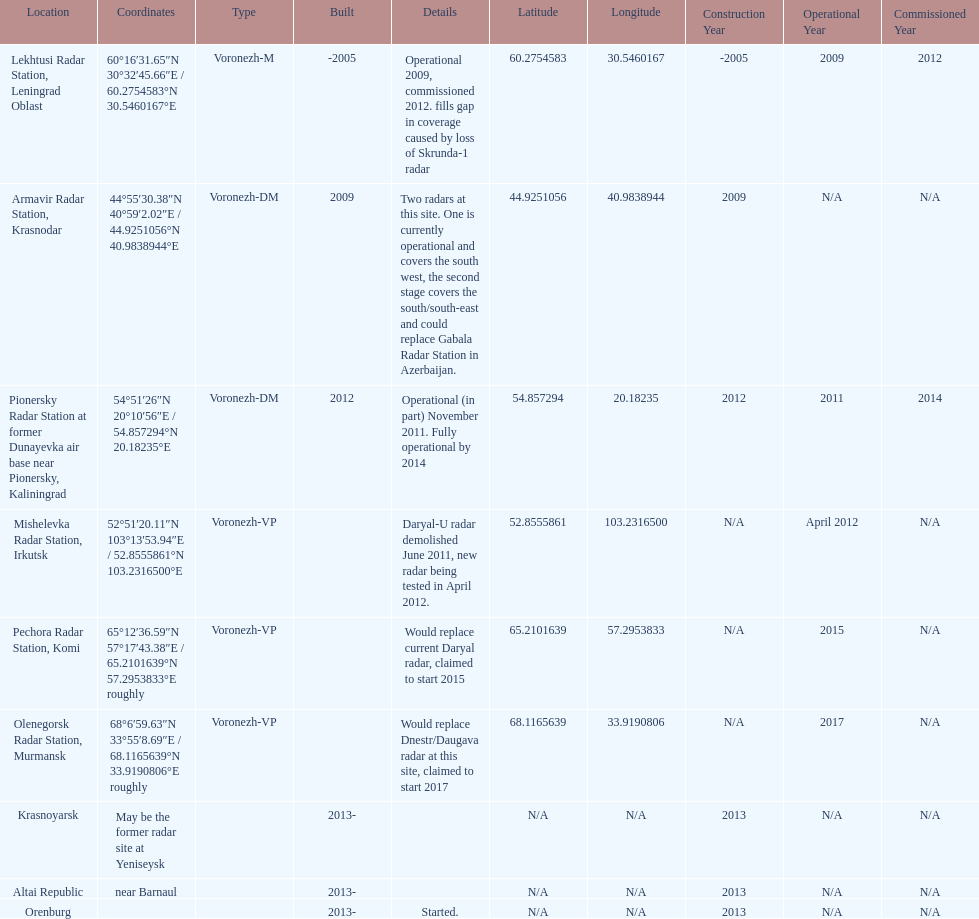How many voronezh radars are in kaliningrad or in krasnodar? 2. 